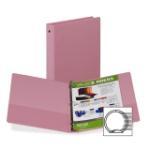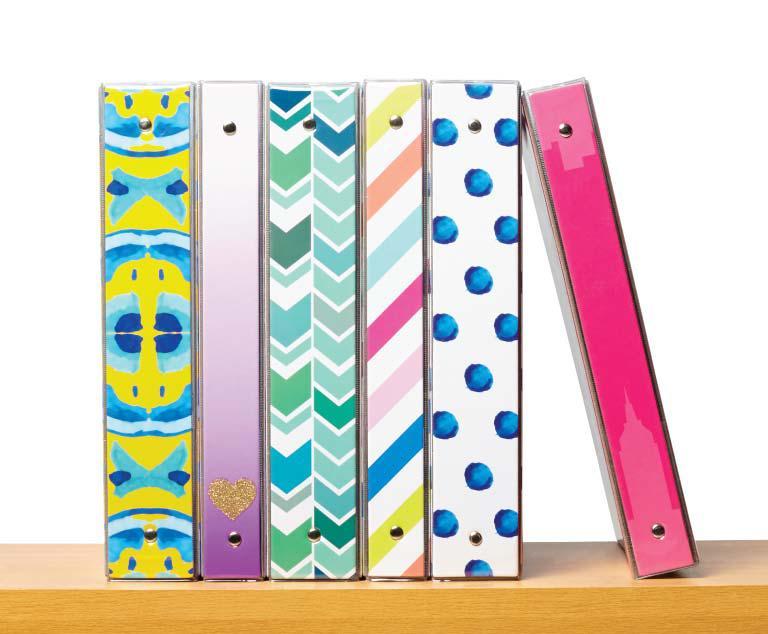The first image is the image on the left, the second image is the image on the right. For the images displayed, is the sentence "The right image image depicts no more than three binders." factually correct? Answer yes or no. No. 